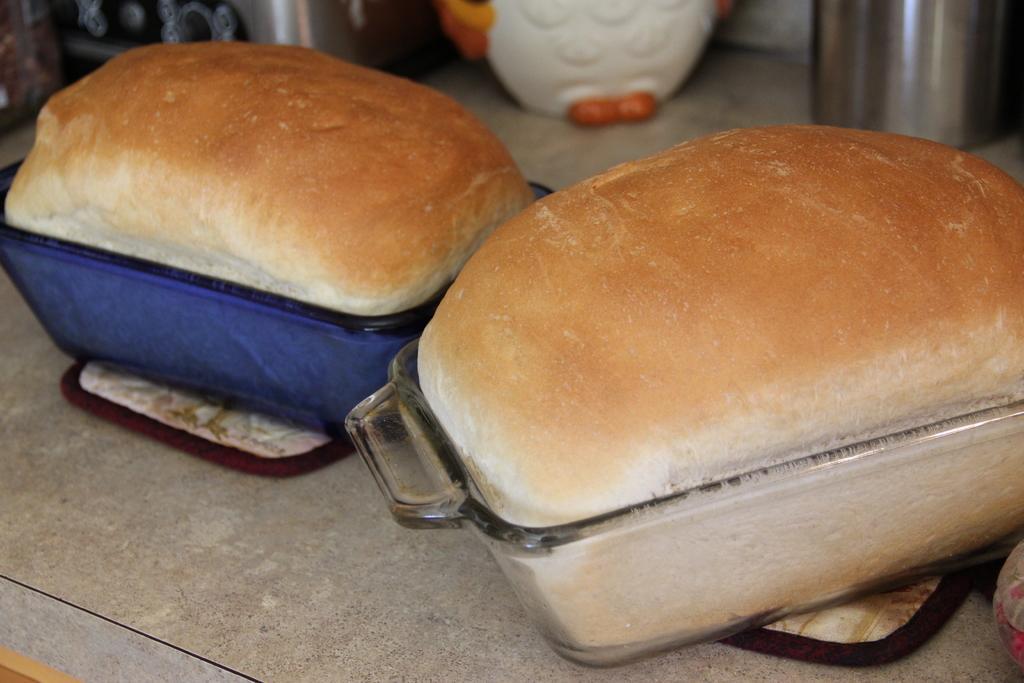How would you summarize this image in a sentence or two? In this image, we can see buns in the glass bowls and there are some containers and some mats are on the table. 